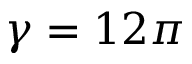Convert formula to latex. <formula><loc_0><loc_0><loc_500><loc_500>\gamma = 1 2 \pi</formula> 